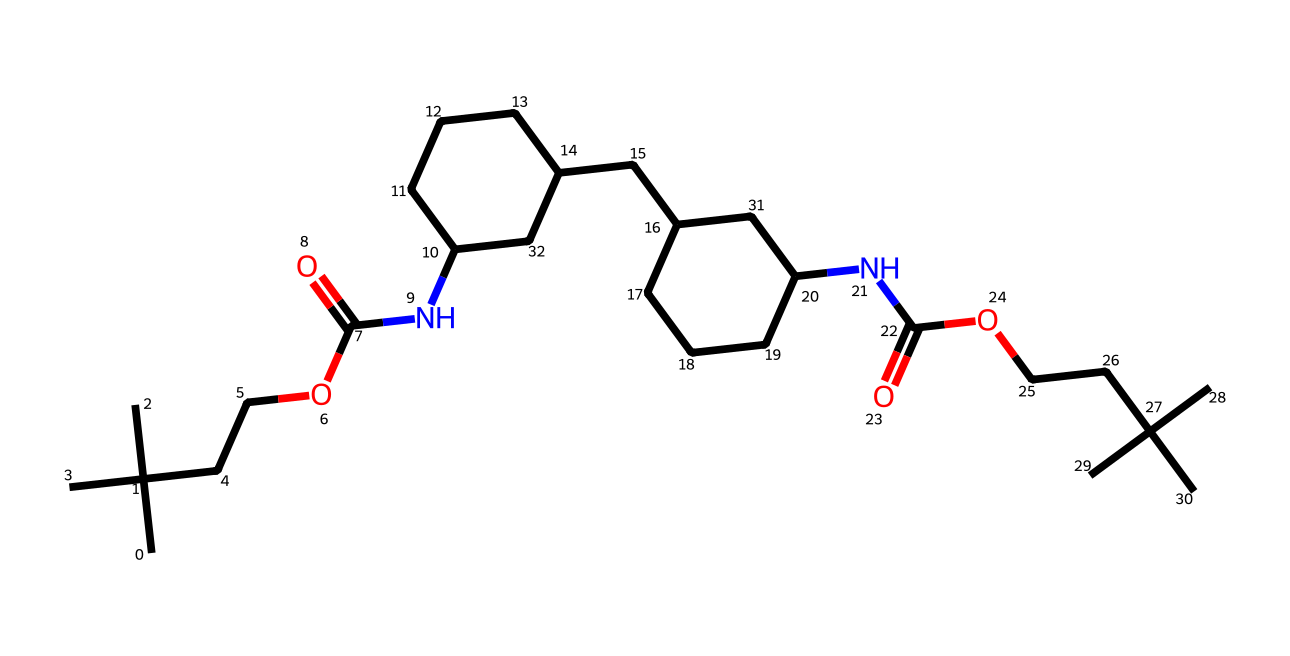what is the main functional group present in this compound? The compound contains an amide functional group indicated by the presence of the nitrogen atom bonded to a carbonyl group (C=O) and the adjacent chain.
Answer: amide how many carbon atoms are present in the structure? Counting the carbon atoms represented in the structure, there are 20 carbon atoms in total.
Answer: 20 what type of linkage does this compound primarily contain? The compound exhibits amide linkages due to the connection between the carbonyl and the nitrogen atoms, which are typical in polyurethanes.
Answer: amide what is the total number of nitrogen atoms in the chemical structure? By analyzing the SMILES representation, there are 2 nitrogen atoms present in the compound.
Answer: 2 does this compound include any ester functional groups? The structural representation indicates an ester functional group defined by the carbonyl connected to an -O- (alkoxy) group, confirming the presence of esters in the composition.
Answer: yes what type of polymer is represented by this chemical structure? The structure corresponds to a polyurethane polymer, which is established by the alternating sequence of the isocyanate and alcohol functionalities leading to the polymer formation.
Answer: polyurethane 